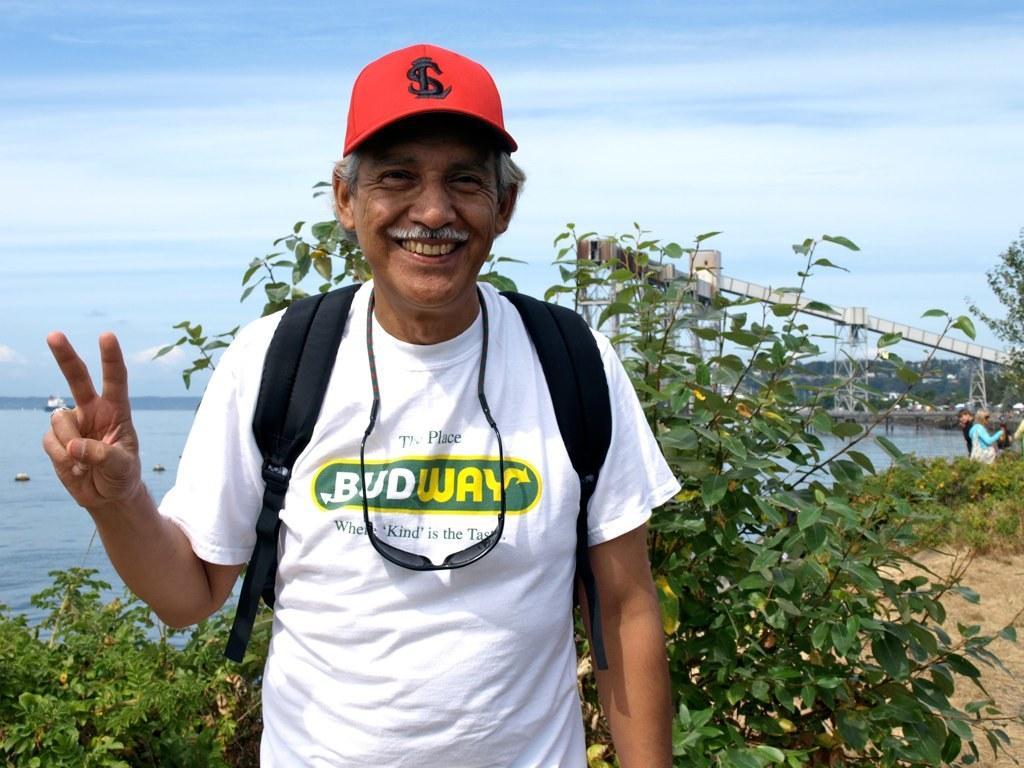In one or two sentences, can you explain what this image depicts? In this image, there is an outside view. In the foreground, there is a person wearing clothes and standing in front of the plant. There is a lake in the middle of the image. In the background, there is a sky. 